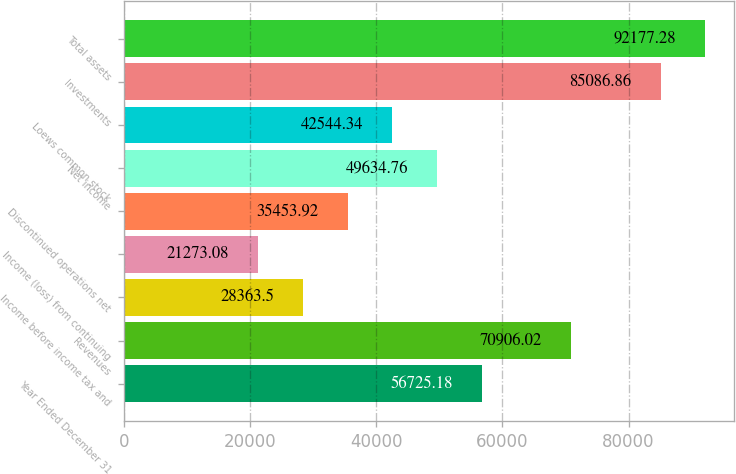<chart> <loc_0><loc_0><loc_500><loc_500><bar_chart><fcel>Year Ended December 31<fcel>Revenues<fcel>Income before income tax and<fcel>Income (loss) from continuing<fcel>Discontinued operations net<fcel>Net income<fcel>Loews common stock<fcel>Investments<fcel>Total assets<nl><fcel>56725.2<fcel>70906<fcel>28363.5<fcel>21273.1<fcel>35453.9<fcel>49634.8<fcel>42544.3<fcel>85086.9<fcel>92177.3<nl></chart> 